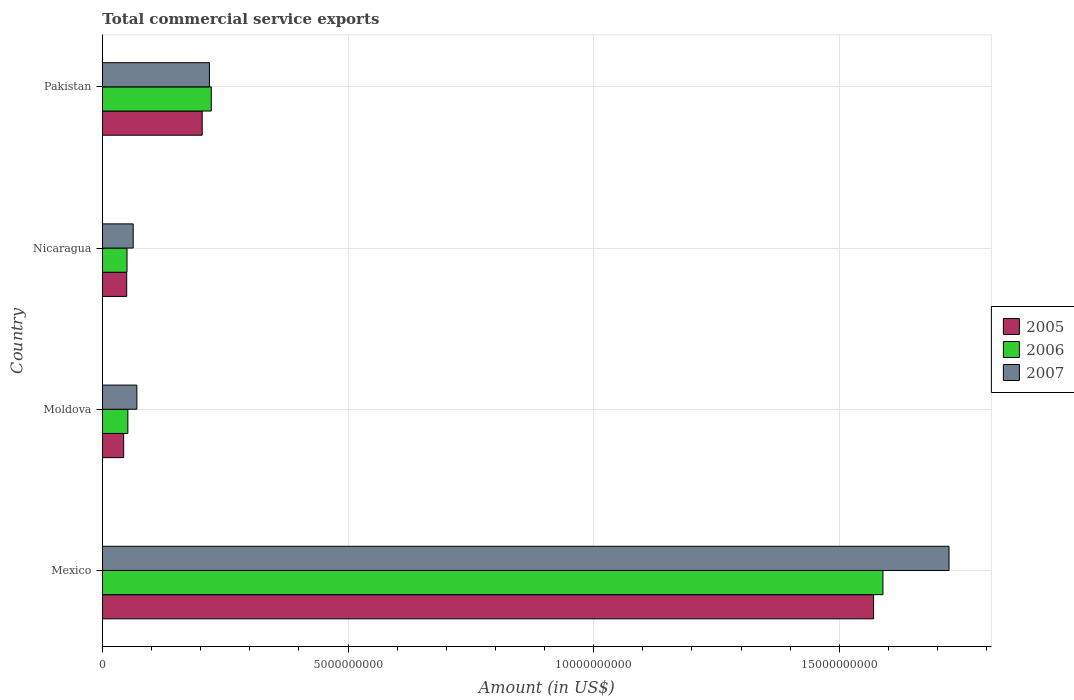How many different coloured bars are there?
Make the answer very short. 3. How many groups of bars are there?
Ensure brevity in your answer.  4. Are the number of bars per tick equal to the number of legend labels?
Give a very brief answer. Yes. How many bars are there on the 1st tick from the top?
Offer a very short reply. 3. How many bars are there on the 3rd tick from the bottom?
Offer a terse response. 3. What is the label of the 1st group of bars from the top?
Your answer should be compact. Pakistan. In how many cases, is the number of bars for a given country not equal to the number of legend labels?
Ensure brevity in your answer.  0. What is the total commercial service exports in 2005 in Nicaragua?
Provide a short and direct response. 4.93e+08. Across all countries, what is the maximum total commercial service exports in 2007?
Your answer should be very brief. 1.72e+1. Across all countries, what is the minimum total commercial service exports in 2006?
Ensure brevity in your answer.  5.00e+08. In which country was the total commercial service exports in 2006 minimum?
Ensure brevity in your answer.  Nicaragua. What is the total total commercial service exports in 2007 in the graph?
Provide a short and direct response. 2.07e+1. What is the difference between the total commercial service exports in 2006 in Nicaragua and that in Pakistan?
Offer a terse response. -1.72e+09. What is the difference between the total commercial service exports in 2007 in Moldova and the total commercial service exports in 2006 in Pakistan?
Your answer should be compact. -1.51e+09. What is the average total commercial service exports in 2005 per country?
Provide a short and direct response. 4.66e+09. What is the difference between the total commercial service exports in 2005 and total commercial service exports in 2007 in Mexico?
Offer a terse response. -1.54e+09. In how many countries, is the total commercial service exports in 2005 greater than 15000000000 US$?
Your answer should be very brief. 1. What is the ratio of the total commercial service exports in 2006 in Nicaragua to that in Pakistan?
Give a very brief answer. 0.23. Is the total commercial service exports in 2006 in Mexico less than that in Nicaragua?
Provide a short and direct response. No. Is the difference between the total commercial service exports in 2005 in Moldova and Nicaragua greater than the difference between the total commercial service exports in 2007 in Moldova and Nicaragua?
Give a very brief answer. No. What is the difference between the highest and the second highest total commercial service exports in 2006?
Offer a very short reply. 1.37e+1. What is the difference between the highest and the lowest total commercial service exports in 2005?
Your response must be concise. 1.53e+1. In how many countries, is the total commercial service exports in 2007 greater than the average total commercial service exports in 2007 taken over all countries?
Offer a very short reply. 1. Is the sum of the total commercial service exports in 2007 in Moldova and Nicaragua greater than the maximum total commercial service exports in 2005 across all countries?
Offer a terse response. No. What does the 1st bar from the top in Pakistan represents?
Provide a short and direct response. 2007. Is it the case that in every country, the sum of the total commercial service exports in 2007 and total commercial service exports in 2005 is greater than the total commercial service exports in 2006?
Your answer should be compact. Yes. Are all the bars in the graph horizontal?
Provide a short and direct response. Yes. How many countries are there in the graph?
Your response must be concise. 4. Does the graph contain any zero values?
Make the answer very short. No. What is the title of the graph?
Your response must be concise. Total commercial service exports. Does "2010" appear as one of the legend labels in the graph?
Ensure brevity in your answer.  No. What is the label or title of the X-axis?
Your answer should be compact. Amount (in US$). What is the Amount (in US$) of 2005 in Mexico?
Your answer should be very brief. 1.57e+1. What is the Amount (in US$) of 2006 in Mexico?
Provide a succinct answer. 1.59e+1. What is the Amount (in US$) of 2007 in Mexico?
Ensure brevity in your answer.  1.72e+1. What is the Amount (in US$) in 2005 in Moldova?
Offer a terse response. 4.31e+08. What is the Amount (in US$) in 2006 in Moldova?
Your answer should be very brief. 5.17e+08. What is the Amount (in US$) in 2007 in Moldova?
Ensure brevity in your answer.  7.00e+08. What is the Amount (in US$) of 2005 in Nicaragua?
Offer a terse response. 4.93e+08. What is the Amount (in US$) of 2006 in Nicaragua?
Give a very brief answer. 5.00e+08. What is the Amount (in US$) of 2007 in Nicaragua?
Provide a succinct answer. 6.25e+08. What is the Amount (in US$) in 2005 in Pakistan?
Provide a short and direct response. 2.03e+09. What is the Amount (in US$) of 2006 in Pakistan?
Offer a very short reply. 2.22e+09. What is the Amount (in US$) in 2007 in Pakistan?
Offer a very short reply. 2.18e+09. Across all countries, what is the maximum Amount (in US$) in 2005?
Keep it short and to the point. 1.57e+1. Across all countries, what is the maximum Amount (in US$) of 2006?
Provide a short and direct response. 1.59e+1. Across all countries, what is the maximum Amount (in US$) of 2007?
Your answer should be very brief. 1.72e+1. Across all countries, what is the minimum Amount (in US$) in 2005?
Offer a terse response. 4.31e+08. Across all countries, what is the minimum Amount (in US$) in 2006?
Offer a very short reply. 5.00e+08. Across all countries, what is the minimum Amount (in US$) of 2007?
Your answer should be very brief. 6.25e+08. What is the total Amount (in US$) in 2005 in the graph?
Provide a succinct answer. 1.87e+1. What is the total Amount (in US$) of 2006 in the graph?
Provide a succinct answer. 1.91e+1. What is the total Amount (in US$) in 2007 in the graph?
Provide a succinct answer. 2.07e+1. What is the difference between the Amount (in US$) in 2005 in Mexico and that in Moldova?
Provide a short and direct response. 1.53e+1. What is the difference between the Amount (in US$) of 2006 in Mexico and that in Moldova?
Offer a terse response. 1.54e+1. What is the difference between the Amount (in US$) of 2007 in Mexico and that in Moldova?
Make the answer very short. 1.65e+1. What is the difference between the Amount (in US$) of 2005 in Mexico and that in Nicaragua?
Offer a very short reply. 1.52e+1. What is the difference between the Amount (in US$) of 2006 in Mexico and that in Nicaragua?
Ensure brevity in your answer.  1.54e+1. What is the difference between the Amount (in US$) of 2007 in Mexico and that in Nicaragua?
Your answer should be very brief. 1.66e+1. What is the difference between the Amount (in US$) in 2005 in Mexico and that in Pakistan?
Your response must be concise. 1.37e+1. What is the difference between the Amount (in US$) of 2006 in Mexico and that in Pakistan?
Ensure brevity in your answer.  1.37e+1. What is the difference between the Amount (in US$) of 2007 in Mexico and that in Pakistan?
Your answer should be compact. 1.51e+1. What is the difference between the Amount (in US$) of 2005 in Moldova and that in Nicaragua?
Offer a very short reply. -6.21e+07. What is the difference between the Amount (in US$) of 2006 in Moldova and that in Nicaragua?
Ensure brevity in your answer.  1.72e+07. What is the difference between the Amount (in US$) in 2007 in Moldova and that in Nicaragua?
Keep it short and to the point. 7.50e+07. What is the difference between the Amount (in US$) of 2005 in Moldova and that in Pakistan?
Offer a terse response. -1.60e+09. What is the difference between the Amount (in US$) of 2006 in Moldova and that in Pakistan?
Offer a very short reply. -1.70e+09. What is the difference between the Amount (in US$) in 2007 in Moldova and that in Pakistan?
Keep it short and to the point. -1.48e+09. What is the difference between the Amount (in US$) of 2005 in Nicaragua and that in Pakistan?
Your answer should be very brief. -1.54e+09. What is the difference between the Amount (in US$) of 2006 in Nicaragua and that in Pakistan?
Give a very brief answer. -1.72e+09. What is the difference between the Amount (in US$) of 2007 in Nicaragua and that in Pakistan?
Your answer should be very brief. -1.55e+09. What is the difference between the Amount (in US$) of 2005 in Mexico and the Amount (in US$) of 2006 in Moldova?
Offer a terse response. 1.52e+1. What is the difference between the Amount (in US$) of 2005 in Mexico and the Amount (in US$) of 2007 in Moldova?
Make the answer very short. 1.50e+1. What is the difference between the Amount (in US$) in 2006 in Mexico and the Amount (in US$) in 2007 in Moldova?
Your answer should be compact. 1.52e+1. What is the difference between the Amount (in US$) in 2005 in Mexico and the Amount (in US$) in 2006 in Nicaragua?
Your response must be concise. 1.52e+1. What is the difference between the Amount (in US$) of 2005 in Mexico and the Amount (in US$) of 2007 in Nicaragua?
Ensure brevity in your answer.  1.51e+1. What is the difference between the Amount (in US$) of 2006 in Mexico and the Amount (in US$) of 2007 in Nicaragua?
Provide a succinct answer. 1.53e+1. What is the difference between the Amount (in US$) of 2005 in Mexico and the Amount (in US$) of 2006 in Pakistan?
Keep it short and to the point. 1.35e+1. What is the difference between the Amount (in US$) in 2005 in Mexico and the Amount (in US$) in 2007 in Pakistan?
Offer a very short reply. 1.35e+1. What is the difference between the Amount (in US$) in 2006 in Mexico and the Amount (in US$) in 2007 in Pakistan?
Your answer should be very brief. 1.37e+1. What is the difference between the Amount (in US$) of 2005 in Moldova and the Amount (in US$) of 2006 in Nicaragua?
Give a very brief answer. -6.83e+07. What is the difference between the Amount (in US$) of 2005 in Moldova and the Amount (in US$) of 2007 in Nicaragua?
Your answer should be compact. -1.94e+08. What is the difference between the Amount (in US$) in 2006 in Moldova and the Amount (in US$) in 2007 in Nicaragua?
Ensure brevity in your answer.  -1.09e+08. What is the difference between the Amount (in US$) of 2005 in Moldova and the Amount (in US$) of 2006 in Pakistan?
Provide a succinct answer. -1.78e+09. What is the difference between the Amount (in US$) in 2005 in Moldova and the Amount (in US$) in 2007 in Pakistan?
Provide a succinct answer. -1.75e+09. What is the difference between the Amount (in US$) of 2006 in Moldova and the Amount (in US$) of 2007 in Pakistan?
Your answer should be compact. -1.66e+09. What is the difference between the Amount (in US$) in 2005 in Nicaragua and the Amount (in US$) in 2006 in Pakistan?
Your answer should be very brief. -1.72e+09. What is the difference between the Amount (in US$) of 2005 in Nicaragua and the Amount (in US$) of 2007 in Pakistan?
Offer a terse response. -1.68e+09. What is the difference between the Amount (in US$) of 2006 in Nicaragua and the Amount (in US$) of 2007 in Pakistan?
Ensure brevity in your answer.  -1.68e+09. What is the average Amount (in US$) of 2005 per country?
Give a very brief answer. 4.66e+09. What is the average Amount (in US$) in 2006 per country?
Offer a very short reply. 4.78e+09. What is the average Amount (in US$) in 2007 per country?
Keep it short and to the point. 5.18e+09. What is the difference between the Amount (in US$) of 2005 and Amount (in US$) of 2006 in Mexico?
Your answer should be very brief. -1.91e+08. What is the difference between the Amount (in US$) of 2005 and Amount (in US$) of 2007 in Mexico?
Your answer should be very brief. -1.54e+09. What is the difference between the Amount (in US$) in 2006 and Amount (in US$) in 2007 in Mexico?
Your response must be concise. -1.35e+09. What is the difference between the Amount (in US$) in 2005 and Amount (in US$) in 2006 in Moldova?
Ensure brevity in your answer.  -8.55e+07. What is the difference between the Amount (in US$) of 2005 and Amount (in US$) of 2007 in Moldova?
Ensure brevity in your answer.  -2.69e+08. What is the difference between the Amount (in US$) of 2006 and Amount (in US$) of 2007 in Moldova?
Keep it short and to the point. -1.84e+08. What is the difference between the Amount (in US$) of 2005 and Amount (in US$) of 2006 in Nicaragua?
Ensure brevity in your answer.  -6.20e+06. What is the difference between the Amount (in US$) in 2005 and Amount (in US$) in 2007 in Nicaragua?
Provide a short and direct response. -1.32e+08. What is the difference between the Amount (in US$) of 2006 and Amount (in US$) of 2007 in Nicaragua?
Provide a succinct answer. -1.26e+08. What is the difference between the Amount (in US$) of 2005 and Amount (in US$) of 2006 in Pakistan?
Your answer should be compact. -1.85e+08. What is the difference between the Amount (in US$) in 2005 and Amount (in US$) in 2007 in Pakistan?
Your response must be concise. -1.48e+08. What is the difference between the Amount (in US$) in 2006 and Amount (in US$) in 2007 in Pakistan?
Offer a very short reply. 3.73e+07. What is the ratio of the Amount (in US$) of 2005 in Mexico to that in Moldova?
Your response must be concise. 36.39. What is the ratio of the Amount (in US$) of 2006 in Mexico to that in Moldova?
Your answer should be compact. 30.74. What is the ratio of the Amount (in US$) in 2007 in Mexico to that in Moldova?
Your response must be concise. 24.61. What is the ratio of the Amount (in US$) in 2005 in Mexico to that in Nicaragua?
Give a very brief answer. 31.81. What is the ratio of the Amount (in US$) of 2006 in Mexico to that in Nicaragua?
Ensure brevity in your answer.  31.8. What is the ratio of the Amount (in US$) of 2007 in Mexico to that in Nicaragua?
Your answer should be compact. 27.56. What is the ratio of the Amount (in US$) in 2005 in Mexico to that in Pakistan?
Ensure brevity in your answer.  7.73. What is the ratio of the Amount (in US$) in 2006 in Mexico to that in Pakistan?
Provide a succinct answer. 7.17. What is the ratio of the Amount (in US$) in 2007 in Mexico to that in Pakistan?
Keep it short and to the point. 7.91. What is the ratio of the Amount (in US$) in 2005 in Moldova to that in Nicaragua?
Your response must be concise. 0.87. What is the ratio of the Amount (in US$) in 2006 in Moldova to that in Nicaragua?
Offer a very short reply. 1.03. What is the ratio of the Amount (in US$) in 2007 in Moldova to that in Nicaragua?
Offer a terse response. 1.12. What is the ratio of the Amount (in US$) in 2005 in Moldova to that in Pakistan?
Give a very brief answer. 0.21. What is the ratio of the Amount (in US$) in 2006 in Moldova to that in Pakistan?
Offer a very short reply. 0.23. What is the ratio of the Amount (in US$) in 2007 in Moldova to that in Pakistan?
Your answer should be very brief. 0.32. What is the ratio of the Amount (in US$) in 2005 in Nicaragua to that in Pakistan?
Your answer should be compact. 0.24. What is the ratio of the Amount (in US$) of 2006 in Nicaragua to that in Pakistan?
Provide a short and direct response. 0.23. What is the ratio of the Amount (in US$) of 2007 in Nicaragua to that in Pakistan?
Keep it short and to the point. 0.29. What is the difference between the highest and the second highest Amount (in US$) in 2005?
Give a very brief answer. 1.37e+1. What is the difference between the highest and the second highest Amount (in US$) of 2006?
Ensure brevity in your answer.  1.37e+1. What is the difference between the highest and the second highest Amount (in US$) in 2007?
Your answer should be compact. 1.51e+1. What is the difference between the highest and the lowest Amount (in US$) in 2005?
Provide a succinct answer. 1.53e+1. What is the difference between the highest and the lowest Amount (in US$) in 2006?
Keep it short and to the point. 1.54e+1. What is the difference between the highest and the lowest Amount (in US$) in 2007?
Provide a short and direct response. 1.66e+1. 